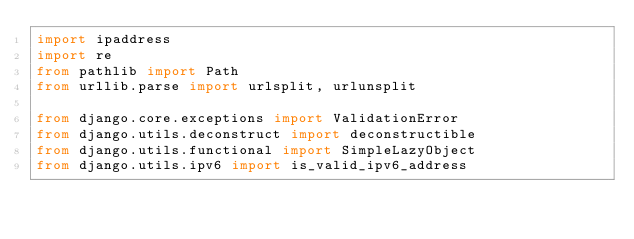Convert code to text. <code><loc_0><loc_0><loc_500><loc_500><_Python_>import ipaddress
import re
from pathlib import Path
from urllib.parse import urlsplit, urlunsplit

from django.core.exceptions import ValidationError
from django.utils.deconstruct import deconstructible
from django.utils.functional import SimpleLazyObject
from django.utils.ipv6 import is_valid_ipv6_address</code> 